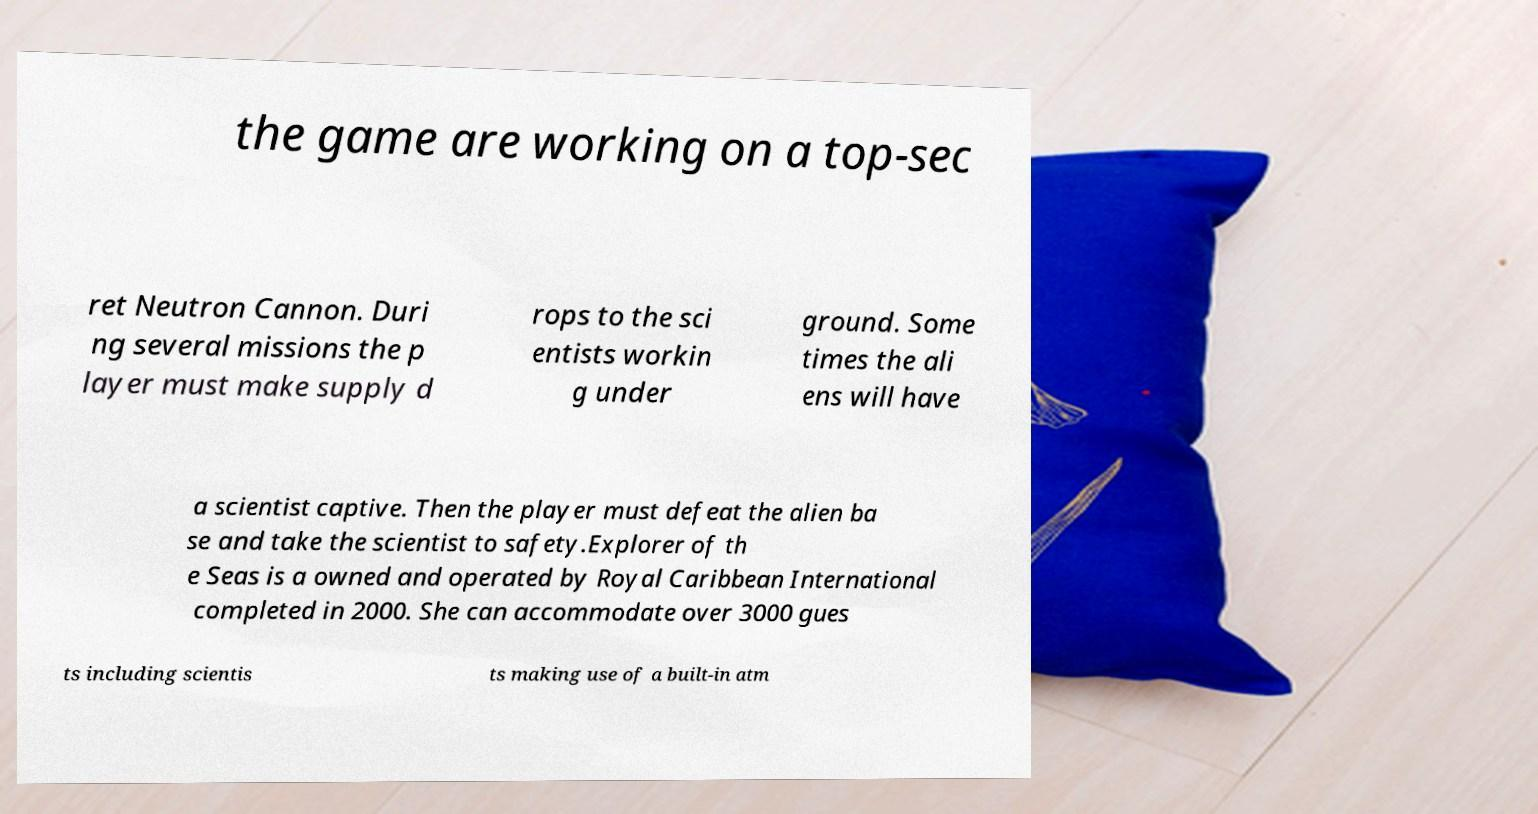For documentation purposes, I need the text within this image transcribed. Could you provide that? the game are working on a top-sec ret Neutron Cannon. Duri ng several missions the p layer must make supply d rops to the sci entists workin g under ground. Some times the ali ens will have a scientist captive. Then the player must defeat the alien ba se and take the scientist to safety.Explorer of th e Seas is a owned and operated by Royal Caribbean International completed in 2000. She can accommodate over 3000 gues ts including scientis ts making use of a built-in atm 